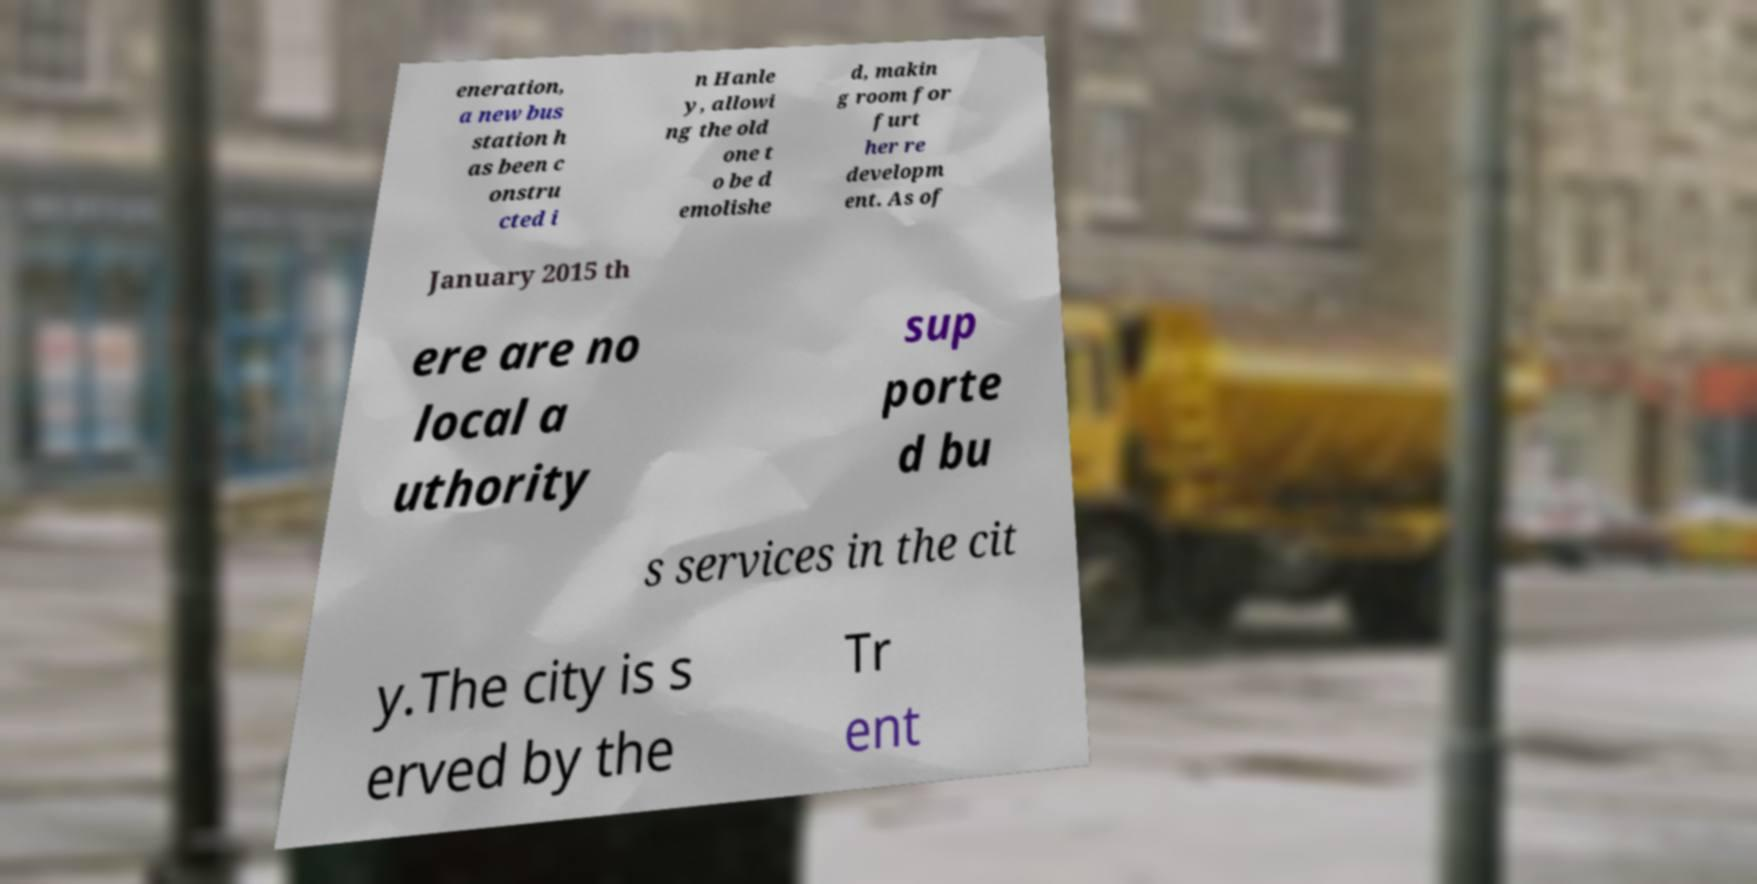For documentation purposes, I need the text within this image transcribed. Could you provide that? eneration, a new bus station h as been c onstru cted i n Hanle y, allowi ng the old one t o be d emolishe d, makin g room for furt her re developm ent. As of January 2015 th ere are no local a uthority sup porte d bu s services in the cit y.The city is s erved by the Tr ent 